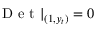<formula> <loc_0><loc_0><loc_500><loc_500>D e t | _ { ( 1 , y _ { t } ) } = 0</formula> 